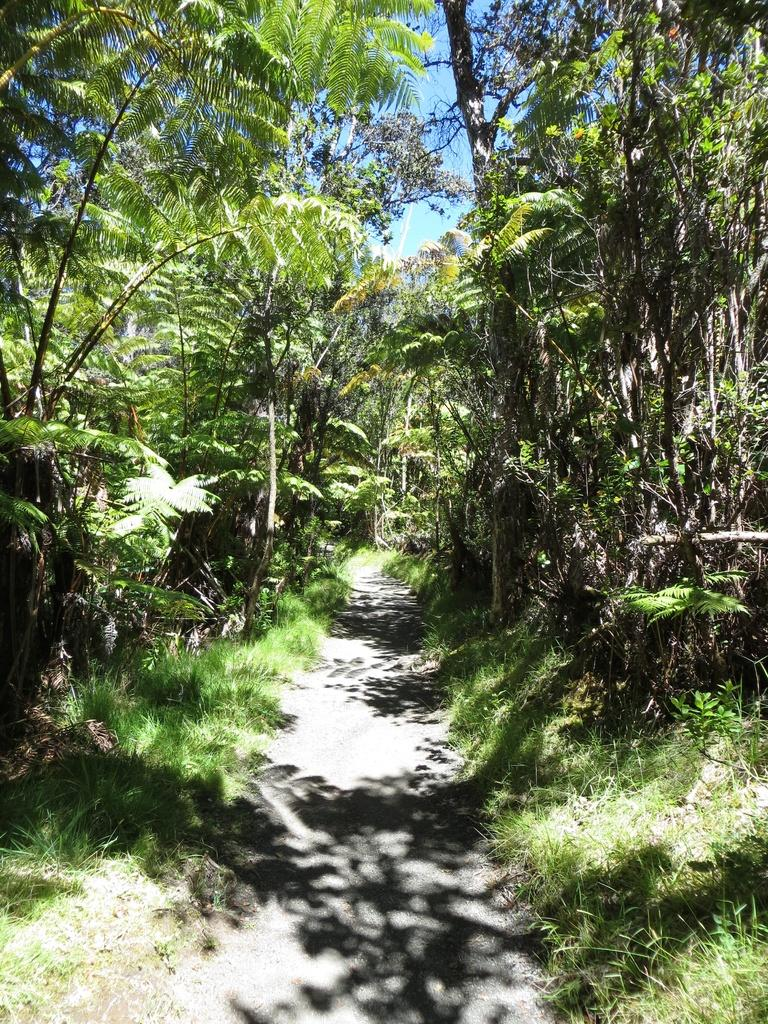What type of vegetation can be seen in the image? There are trees in the image. What else can be seen on the ground in the image? There is grass in the image. What type of waves can be seen crashing against the wall in the image? There are no waves or walls present in the image; it features trees and grass. 